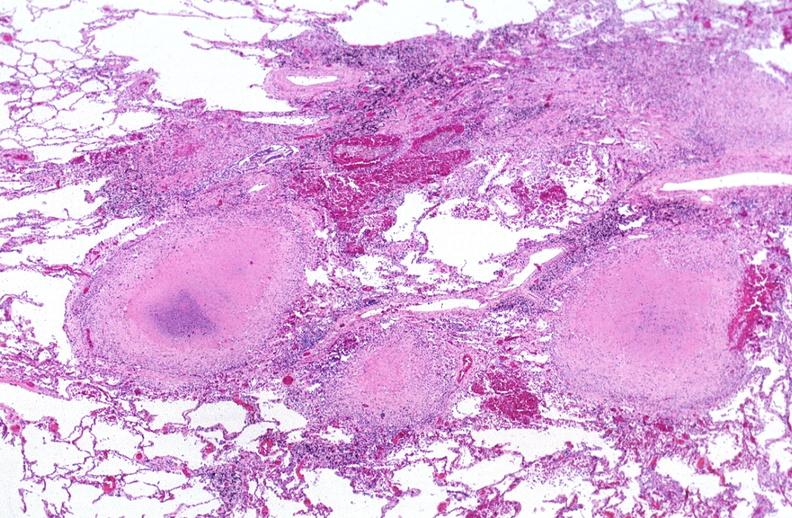what is present?
Answer the question using a single word or phrase. Respiratory 